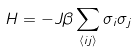<formula> <loc_0><loc_0><loc_500><loc_500>H = - J \beta \sum _ { \langle i j \rangle } \sigma _ { i } \sigma _ { j }</formula> 